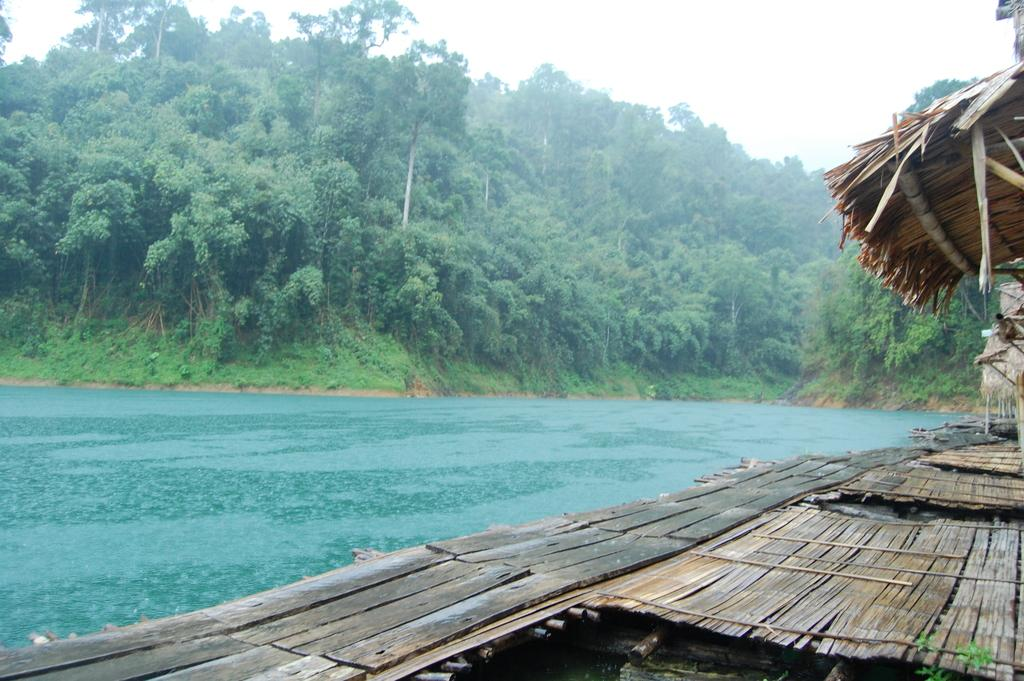What is: What type of structure is present in the image? There is a platform and a hut in the image. What can be seen near the platform and hut? There is water visible in the image. What type of vegetation is present in the image? There are trees in the image. What is visible in the background of the image? The sky is visible in the background of the image. What type of cream can be seen floating on the water in the image? There is no cream visible on the water in the image. 